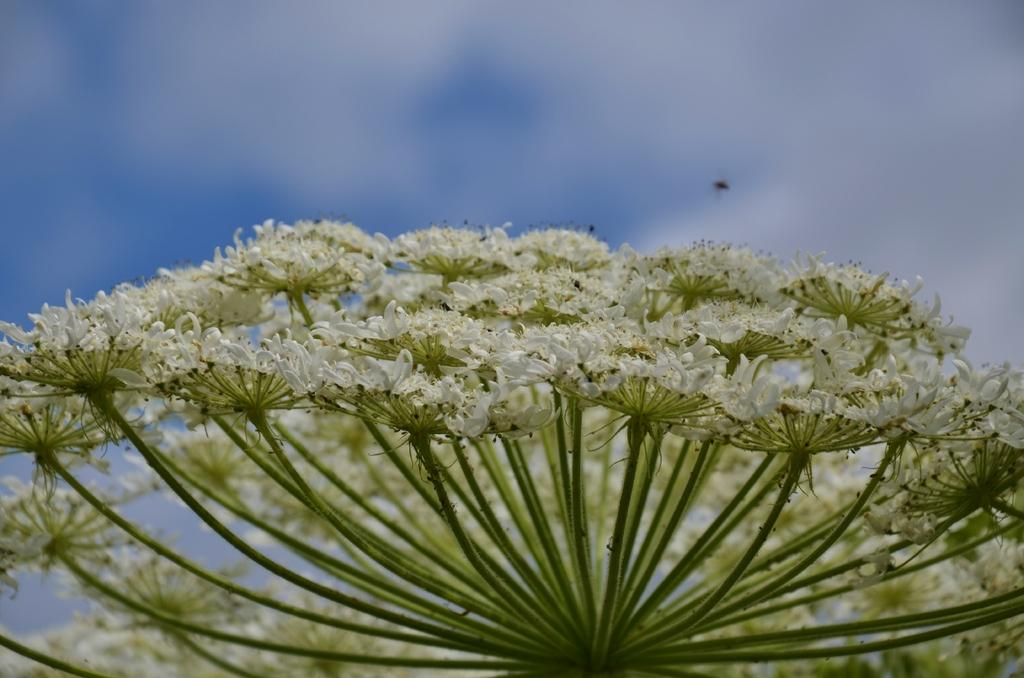What type of flowers are in the image? There are white color flowers in the image. Can you describe the background of the image? The background of the image is blurry. What color is the background of the image? The background color is blue. Where is the mine located in the image? There is no mine present in the image. Can you describe the emotions of the girl in the image? There is no girl present in the image. 